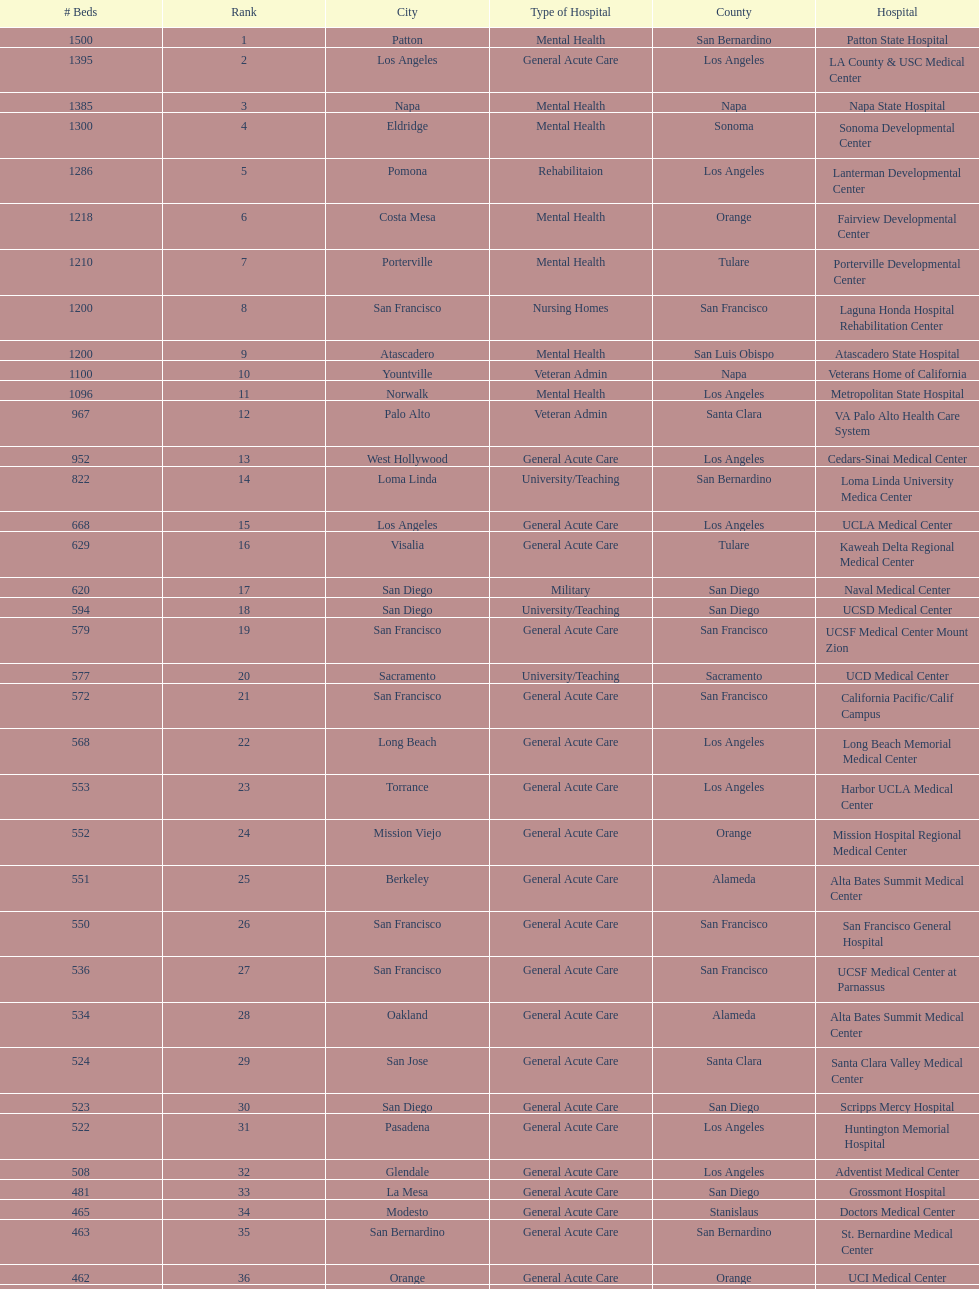How many hospital's have at least 600 beds? 17. 